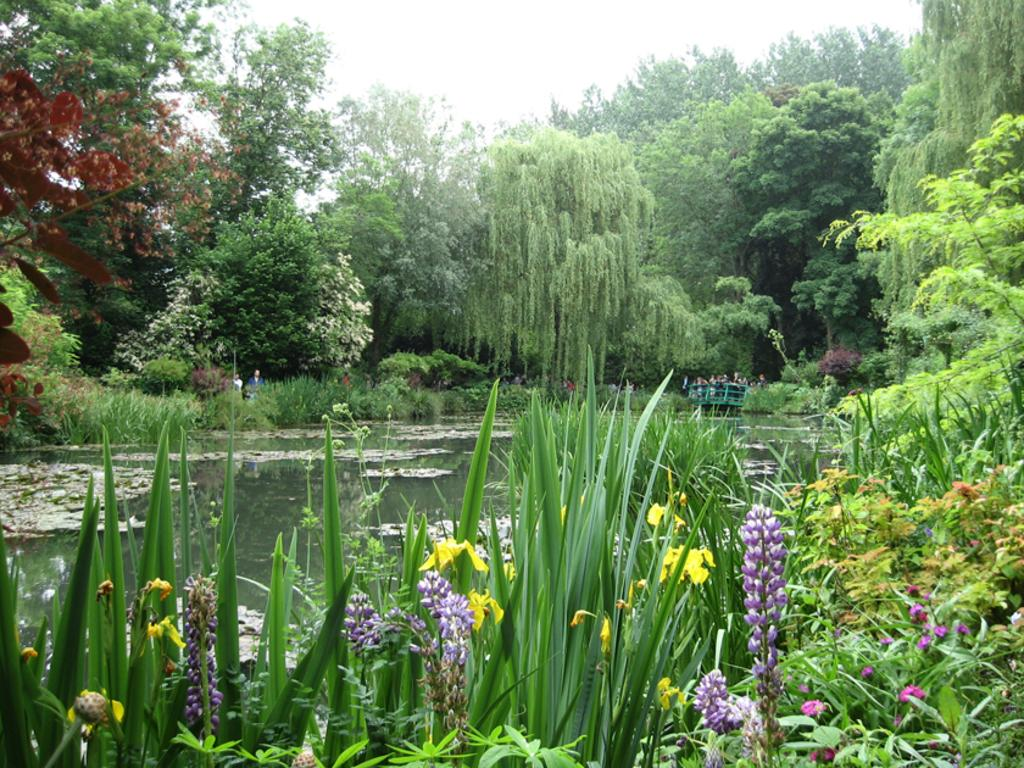What is the main feature in the center of the image? There is water in the center of the image. What can be seen in the background of the image? There are people on a bridge in the background of the image. What type of environment is depicted in the image? There is greenery around the area of the image, suggesting a natural setting. What type of duck can be seen swimming in the water in the image? There are no ducks present in the image; it only features water and a bridge in the background. 